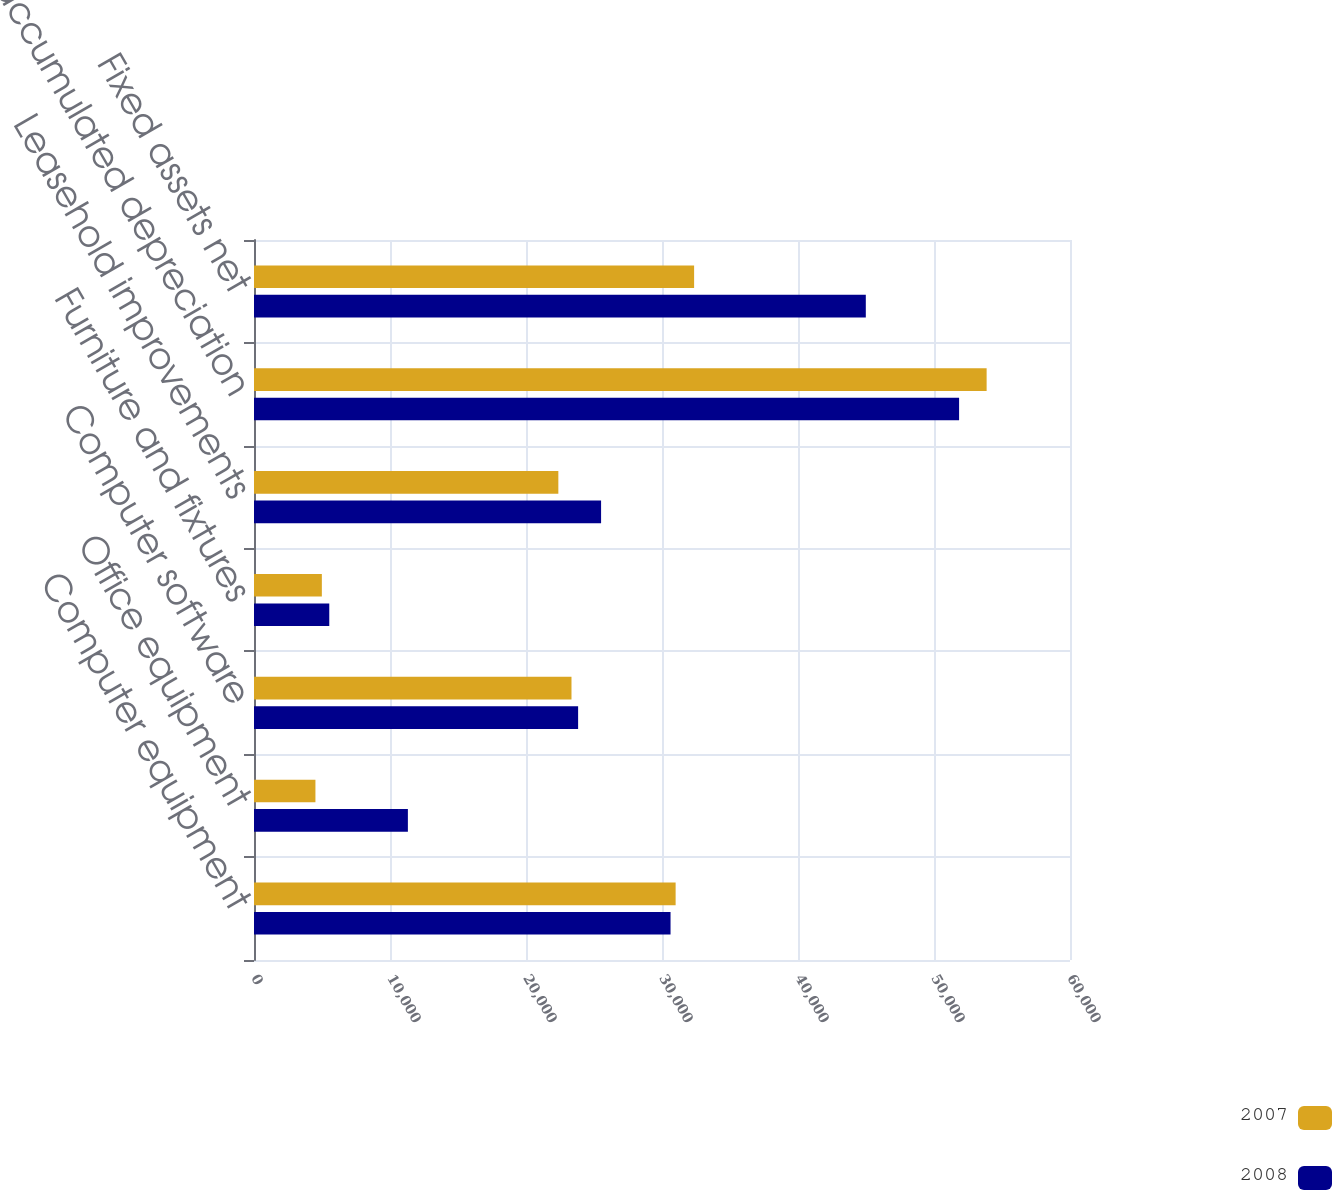Convert chart. <chart><loc_0><loc_0><loc_500><loc_500><stacked_bar_chart><ecel><fcel>Computer equipment<fcel>Office equipment<fcel>Computer software<fcel>Furniture and fixtures<fcel>Leasehold improvements<fcel>Less accumulated depreciation<fcel>Fixed assets net<nl><fcel>2007<fcel>31002<fcel>4517<fcel>23345<fcel>4989<fcel>22378<fcel>53870<fcel>32361<nl><fcel>2008<fcel>30628<fcel>11315<fcel>23832<fcel>5535<fcel>25521<fcel>51845<fcel>44986<nl></chart> 